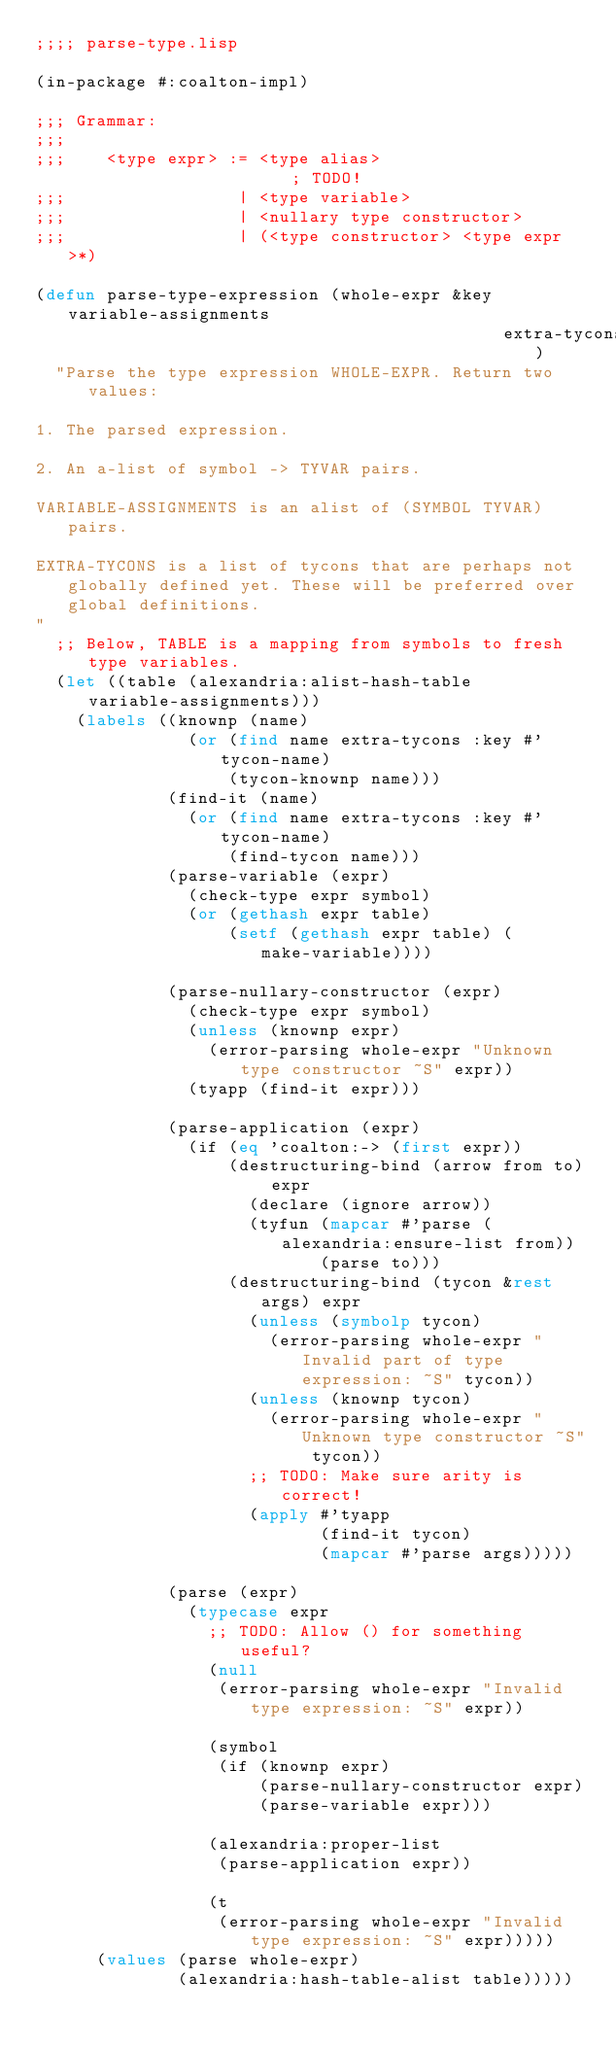<code> <loc_0><loc_0><loc_500><loc_500><_Lisp_>;;;; parse-type.lisp

(in-package #:coalton-impl)

;;; Grammar:
;;;
;;;    <type expr> := <type alias>                       ; TODO!
;;;                 | <type variable>
;;;                 | <nullary type constructor>
;;;                 | (<type constructor> <type expr>*)

(defun parse-type-expression (whole-expr &key variable-assignments
                                              extra-tycons)
  "Parse the type expression WHOLE-EXPR. Return two values:

1. The parsed expression.

2. An a-list of symbol -> TYVAR pairs.

VARIABLE-ASSIGNMENTS is an alist of (SYMBOL TYVAR) pairs.

EXTRA-TYCONS is a list of tycons that are perhaps not globally defined yet. These will be preferred over global definitions.
"
  ;; Below, TABLE is a mapping from symbols to fresh type variables.
  (let ((table (alexandria:alist-hash-table variable-assignments)))
    (labels ((knownp (name)
               (or (find name extra-tycons :key #'tycon-name)
                   (tycon-knownp name)))
             (find-it (name)
               (or (find name extra-tycons :key #'tycon-name)
                   (find-tycon name)))
             (parse-variable (expr)
               (check-type expr symbol)
               (or (gethash expr table)
                   (setf (gethash expr table) (make-variable))))

             (parse-nullary-constructor (expr)
               (check-type expr symbol)
               (unless (knownp expr)
                 (error-parsing whole-expr "Unknown type constructor ~S" expr))
               (tyapp (find-it expr)))

             (parse-application (expr)
               (if (eq 'coalton:-> (first expr))
                   (destructuring-bind (arrow from to) expr
                     (declare (ignore arrow))
                     (tyfun (mapcar #'parse (alexandria:ensure-list from))
                            (parse to)))
                   (destructuring-bind (tycon &rest args) expr
                     (unless (symbolp tycon)
                       (error-parsing whole-expr "Invalid part of type expression: ~S" tycon))
                     (unless (knownp tycon)
                       (error-parsing whole-expr "Unknown type constructor ~S" tycon))
                     ;; TODO: Make sure arity is correct!
                     (apply #'tyapp
                            (find-it tycon)
                            (mapcar #'parse args)))))

             (parse (expr)
               (typecase expr
                 ;; TODO: Allow () for something useful?
                 (null
                  (error-parsing whole-expr "Invalid type expression: ~S" expr))

                 (symbol
                  (if (knownp expr)
                      (parse-nullary-constructor expr)
                      (parse-variable expr)))

                 (alexandria:proper-list
                  (parse-application expr))

                 (t
                  (error-parsing whole-expr "Invalid type expression: ~S" expr)))))
      (values (parse whole-expr)
              (alexandria:hash-table-alist table)))))
</code> 